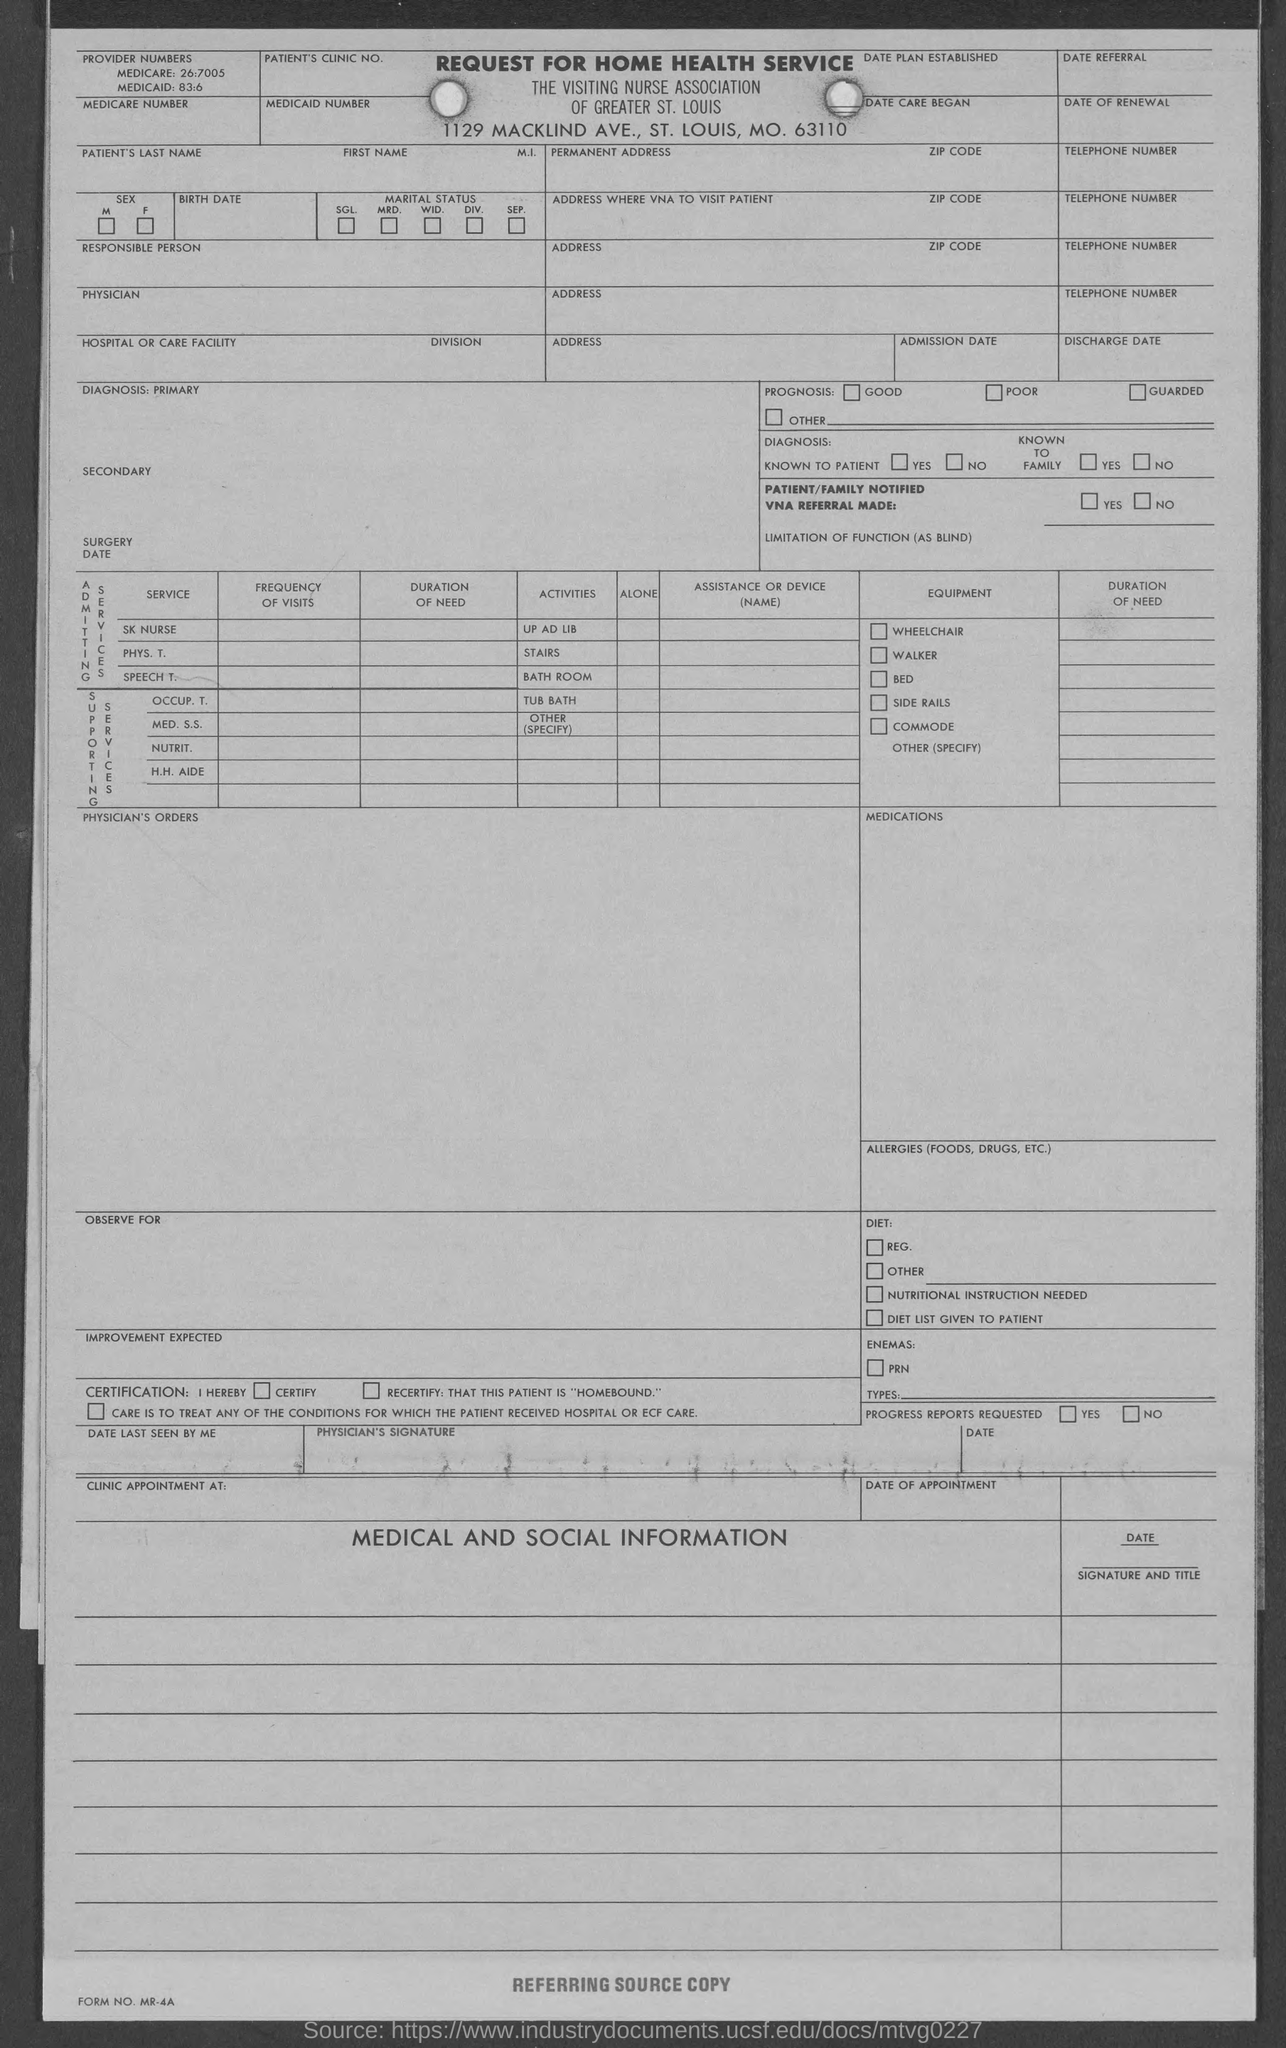Identify some key points in this picture. The Medicare number provided in the given form is 26:7005. The Medicaid number mentioned in the given form is 83:6. 